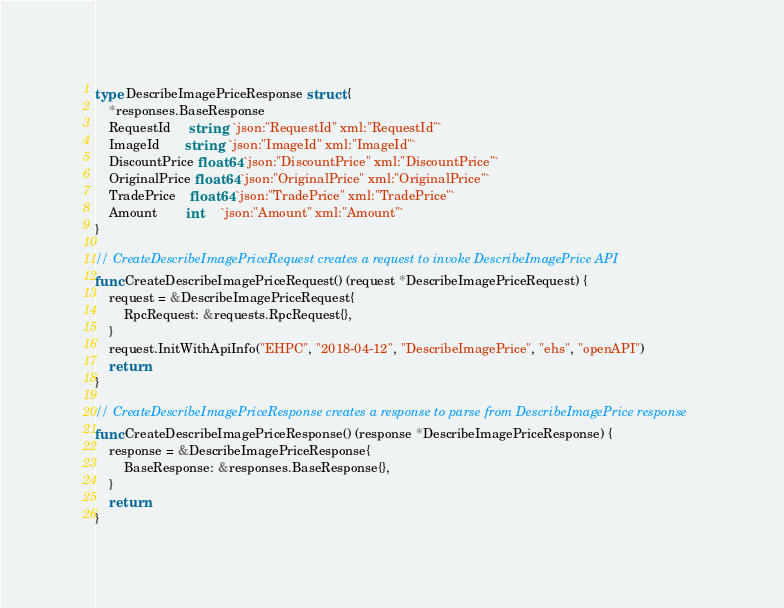<code> <loc_0><loc_0><loc_500><loc_500><_Go_>type DescribeImagePriceResponse struct {
	*responses.BaseResponse
	RequestId     string  `json:"RequestId" xml:"RequestId"`
	ImageId       string  `json:"ImageId" xml:"ImageId"`
	DiscountPrice float64 `json:"DiscountPrice" xml:"DiscountPrice"`
	OriginalPrice float64 `json:"OriginalPrice" xml:"OriginalPrice"`
	TradePrice    float64 `json:"TradePrice" xml:"TradePrice"`
	Amount        int     `json:"Amount" xml:"Amount"`
}

// CreateDescribeImagePriceRequest creates a request to invoke DescribeImagePrice API
func CreateDescribeImagePriceRequest() (request *DescribeImagePriceRequest) {
	request = &DescribeImagePriceRequest{
		RpcRequest: &requests.RpcRequest{},
	}
	request.InitWithApiInfo("EHPC", "2018-04-12", "DescribeImagePrice", "ehs", "openAPI")
	return
}

// CreateDescribeImagePriceResponse creates a response to parse from DescribeImagePrice response
func CreateDescribeImagePriceResponse() (response *DescribeImagePriceResponse) {
	response = &DescribeImagePriceResponse{
		BaseResponse: &responses.BaseResponse{},
	}
	return
}
</code> 